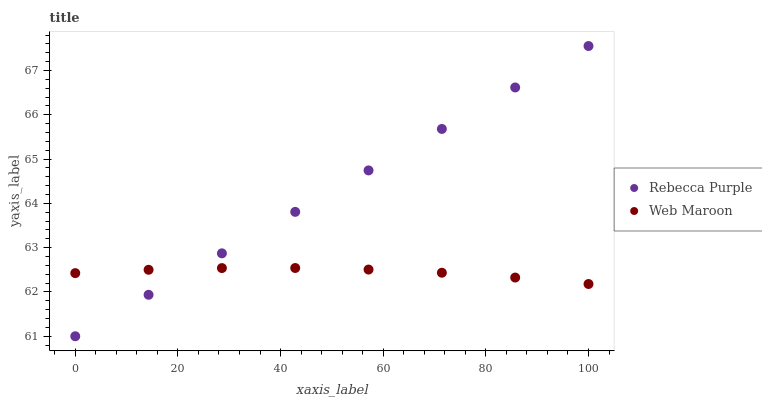Does Web Maroon have the minimum area under the curve?
Answer yes or no. Yes. Does Rebecca Purple have the maximum area under the curve?
Answer yes or no. Yes. Does Rebecca Purple have the minimum area under the curve?
Answer yes or no. No. Is Rebecca Purple the smoothest?
Answer yes or no. Yes. Is Web Maroon the roughest?
Answer yes or no. Yes. Is Rebecca Purple the roughest?
Answer yes or no. No. Does Rebecca Purple have the lowest value?
Answer yes or no. Yes. Does Rebecca Purple have the highest value?
Answer yes or no. Yes. Does Rebecca Purple intersect Web Maroon?
Answer yes or no. Yes. Is Rebecca Purple less than Web Maroon?
Answer yes or no. No. Is Rebecca Purple greater than Web Maroon?
Answer yes or no. No. 